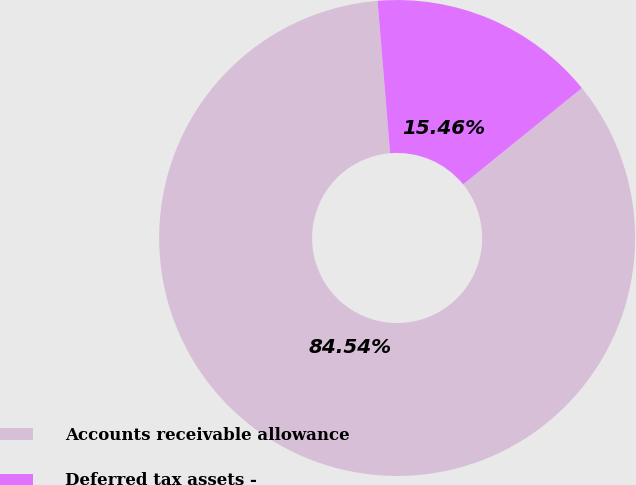Convert chart to OTSL. <chart><loc_0><loc_0><loc_500><loc_500><pie_chart><fcel>Accounts receivable allowance<fcel>Deferred tax assets -<nl><fcel>84.54%<fcel>15.46%<nl></chart> 